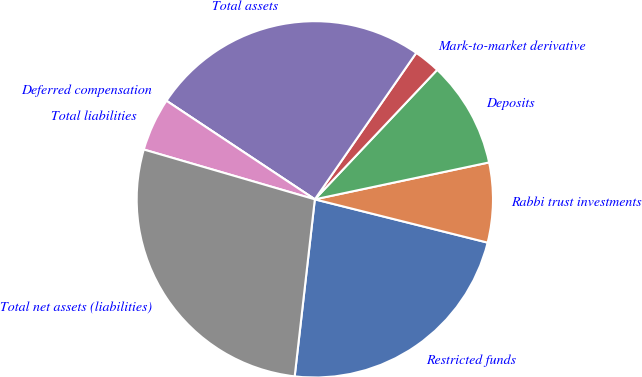<chart> <loc_0><loc_0><loc_500><loc_500><pie_chart><fcel>Restricted funds<fcel>Rabbi trust investments<fcel>Deposits<fcel>Mark-to-market derivative<fcel>Total assets<fcel>Deferred compensation<fcel>Total liabilities<fcel>Total net assets (liabilities)<nl><fcel>22.9%<fcel>7.23%<fcel>9.63%<fcel>2.41%<fcel>25.31%<fcel>0.0%<fcel>4.82%<fcel>27.71%<nl></chart> 